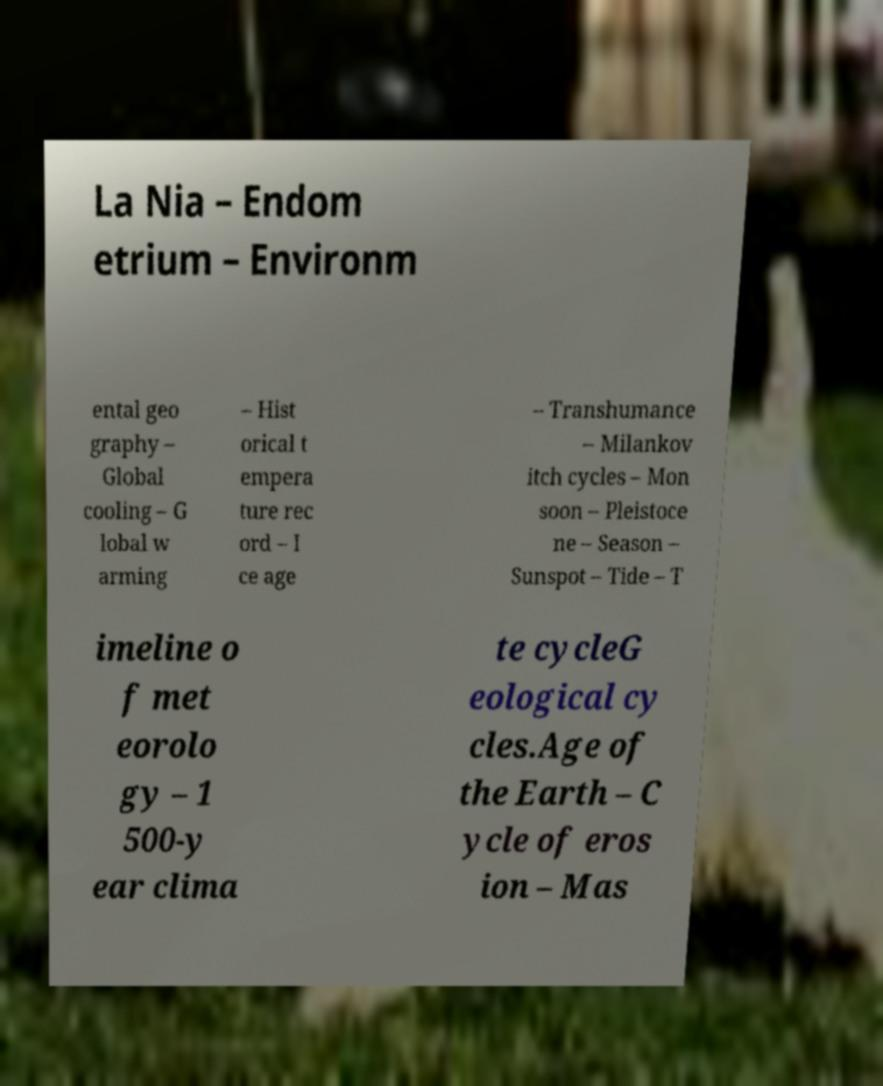Can you accurately transcribe the text from the provided image for me? La Nia – Endom etrium – Environm ental geo graphy – Global cooling – G lobal w arming – Hist orical t empera ture rec ord – I ce age – Transhumance – Milankov itch cycles – Mon soon – Pleistoce ne – Season – Sunspot – Tide – T imeline o f met eorolo gy – 1 500-y ear clima te cycleG eological cy cles.Age of the Earth – C ycle of eros ion – Mas 